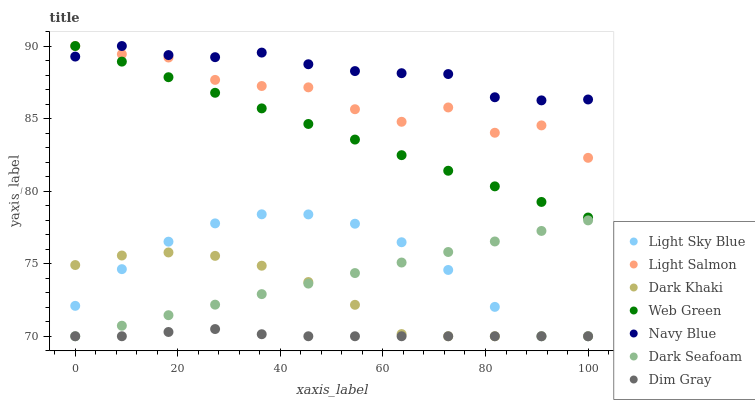Does Dim Gray have the minimum area under the curve?
Answer yes or no. Yes. Does Navy Blue have the maximum area under the curve?
Answer yes or no. Yes. Does Navy Blue have the minimum area under the curve?
Answer yes or no. No. Does Dim Gray have the maximum area under the curve?
Answer yes or no. No. Is Dark Seafoam the smoothest?
Answer yes or no. Yes. Is Light Salmon the roughest?
Answer yes or no. Yes. Is Dim Gray the smoothest?
Answer yes or no. No. Is Dim Gray the roughest?
Answer yes or no. No. Does Dim Gray have the lowest value?
Answer yes or no. Yes. Does Navy Blue have the lowest value?
Answer yes or no. No. Does Web Green have the highest value?
Answer yes or no. Yes. Does Dim Gray have the highest value?
Answer yes or no. No. Is Dim Gray less than Navy Blue?
Answer yes or no. Yes. Is Light Salmon greater than Dark Seafoam?
Answer yes or no. Yes. Does Light Sky Blue intersect Dark Seafoam?
Answer yes or no. Yes. Is Light Sky Blue less than Dark Seafoam?
Answer yes or no. No. Is Light Sky Blue greater than Dark Seafoam?
Answer yes or no. No. Does Dim Gray intersect Navy Blue?
Answer yes or no. No. 